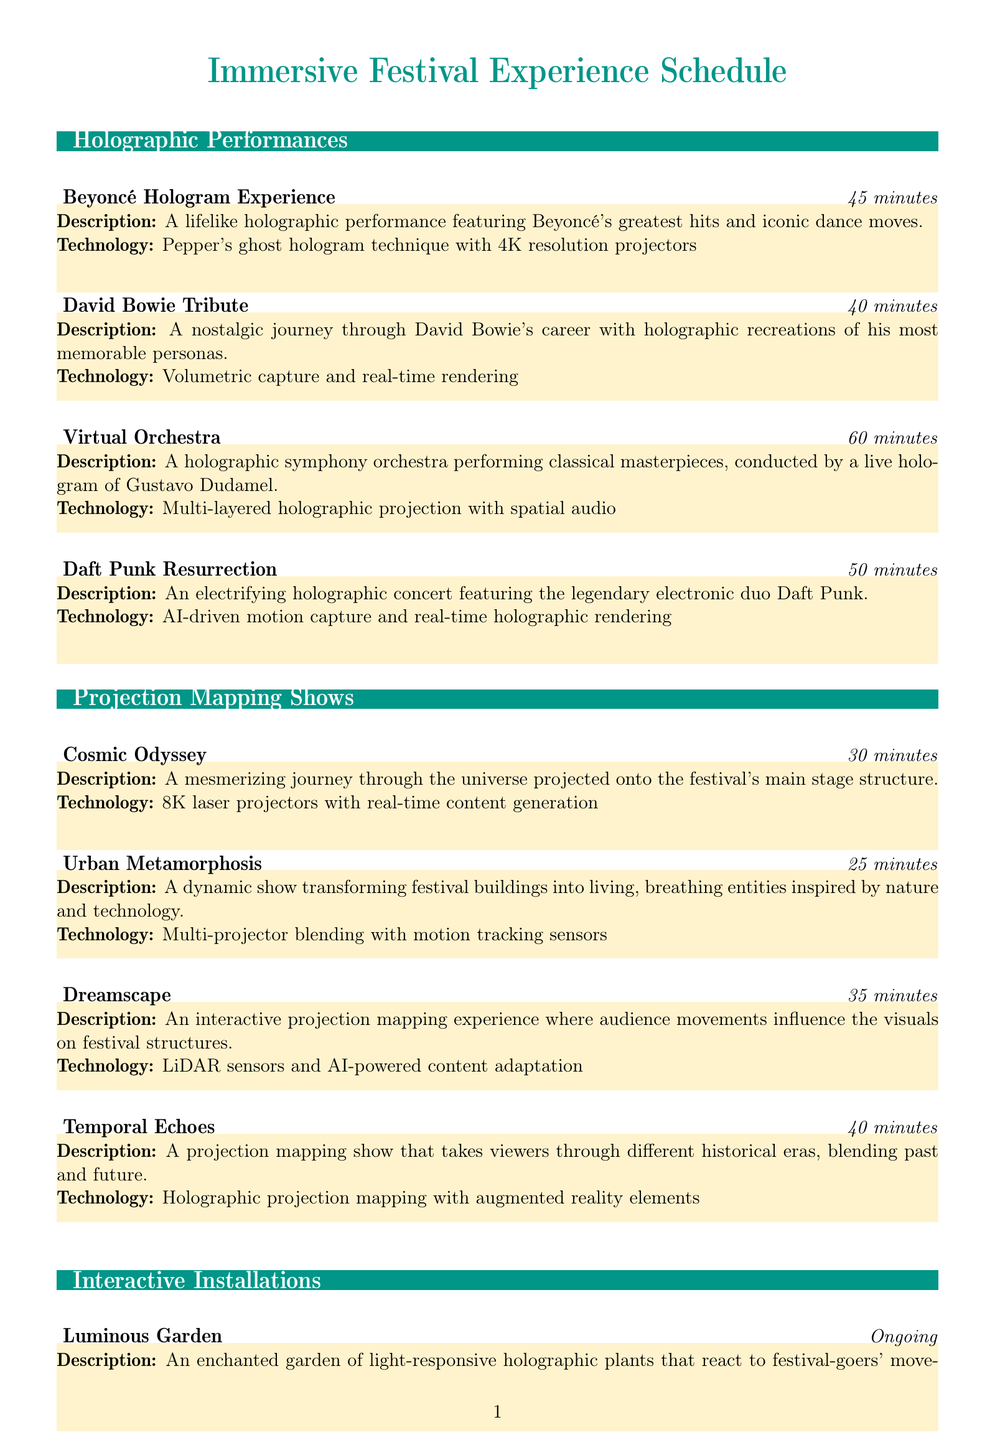what is the duration of the Beyoncé Hologram Experience? The duration is provided in the document for each performance; for the Beyoncé Hologram Experience, it is 45 minutes.
Answer: 45 minutes how long is the Daft Punk Resurrection show? Each performance's duration is stated in the document; the Daft Punk Resurrection show lasts 50 minutes.
Answer: 50 minutes what technology is used for the Dreamscape show? The technology used for the Dreamscape show is specified, which includes LiDAR sensors and AI-powered content adaptation.
Answer: LiDAR sensors and AI-powered content adaptation which performance has the longest duration? To find the longest duration, I need to compare the durations of all holographic performances and identify the longest one, which is the Virtual Orchestra at 60 minutes.
Answer: Virtual Orchestra how many interactive installations are ongoing? The document lists four interactive installations, specifically noting that their duration is ongoing.
Answer: 4 what is the main theme of the Urban Metamorphosis show? The document describes the Urban Metamorphosis as transforming festival buildings into living, breathing entities inspired by nature and technology.
Answer: inspired by nature and technology how many minutes is the total duration of projection mapping shows? To find the total duration, I need to add the durations of all projection mapping shows listed in the document. The total is 30 + 25 + 35 + 40 = 130 minutes.
Answer: 130 minutes what type of technology is used in the Luminous Garden installation? The technology used for the Luminous Garden installation is provided, which involves motion sensors and real-time holographic rendering.
Answer: Motion sensors and real-time holographic rendering what is the main feature of the Holographic Time Capsule? The main feature is described as a booth where festival-goers can record holographic messages to be played at future festivals.
Answer: record holographic messages 